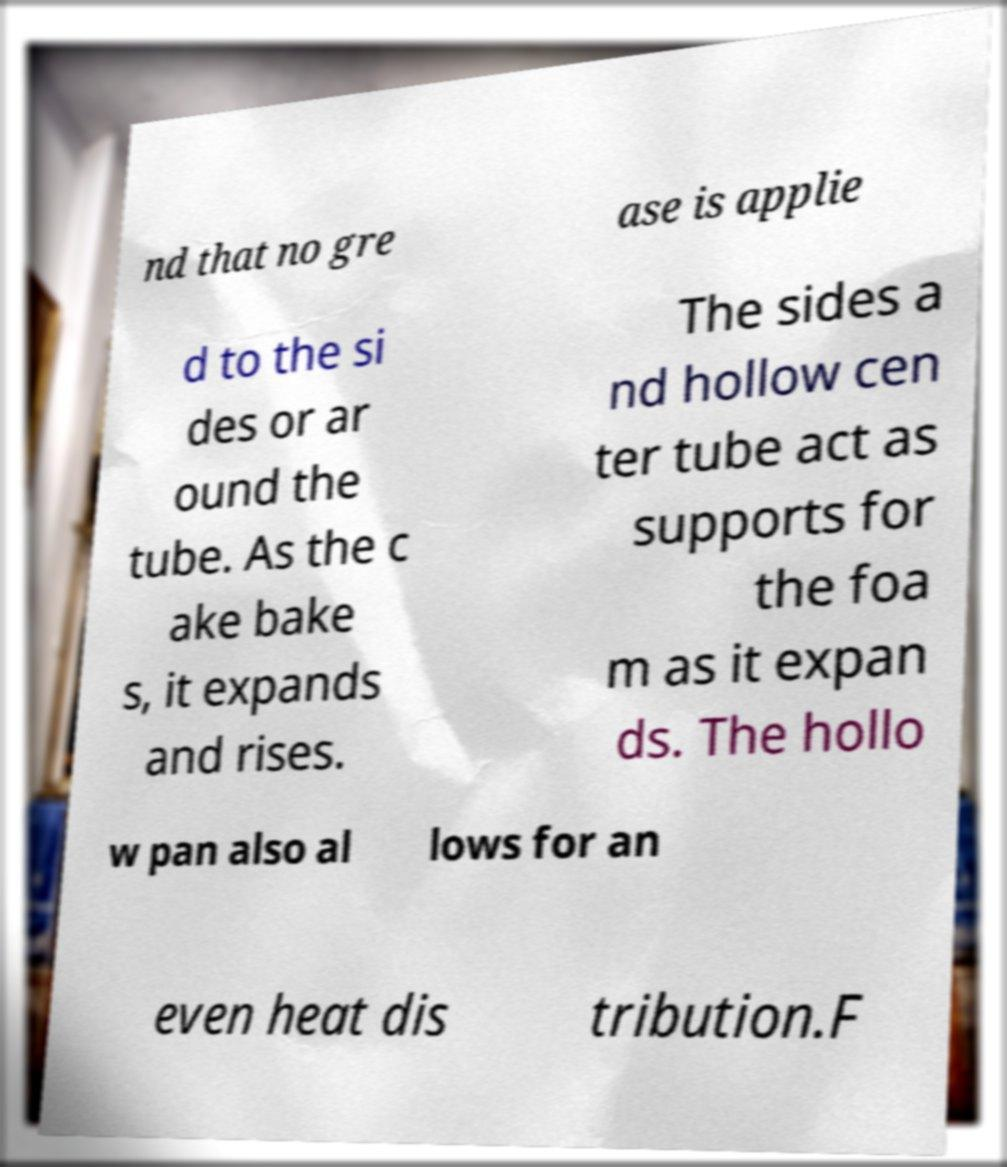Can you accurately transcribe the text from the provided image for me? nd that no gre ase is applie d to the si des or ar ound the tube. As the c ake bake s, it expands and rises. The sides a nd hollow cen ter tube act as supports for the foa m as it expan ds. The hollo w pan also al lows for an even heat dis tribution.F 